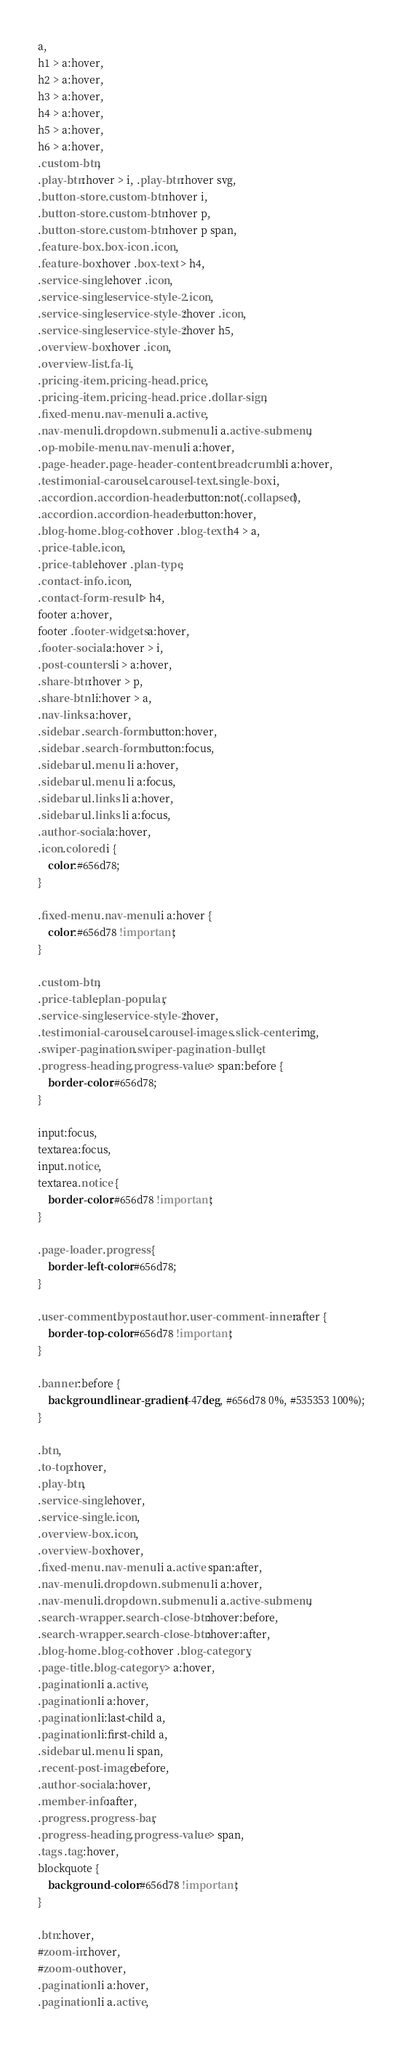Convert code to text. <code><loc_0><loc_0><loc_500><loc_500><_CSS_>a,
h1 > a:hover, 
h2 > a:hover, 
h3 > a:hover, 
h4 > a:hover, 
h5 > a:hover, 
h6 > a:hover,
.custom-btn,
.play-btn:hover > i, .play-btn:hover svg,
.button-store .custom-btn:hover i,
.button-store .custom-btn:hover p,
.button-store .custom-btn:hover p span,
.feature-box .box-icon .icon,
.feature-box:hover .box-text > h4,
.service-single:hover .icon,
.service-single.service-style-2 .icon,
.service-single.service-style-2:hover .icon,
.service-single.service-style-2:hover h5,
.overview-box:hover .icon,
.overview-list .fa-li,
.pricing-item .pricing-head .price,
.pricing-item .pricing-head .price .dollar-sign,
.fixed-menu .nav-menu li a.active,
.nav-menu li.dropdown .submenu li a.active-submenu,
.op-mobile-menu .nav-menu li a:hover,
.page-header .page-header-content .breadcrumb li a:hover,
.testimonial-carousel .carousel-text .single-box i,
.accordion .accordion-header button:not(.collapsed),
.accordion .accordion-header button:hover,
.blog-home .blog-col:hover .blog-text h4 > a,
.price-table .icon,
.price-table:hover .plan-type,
.contact-info .icon,
.contact-form-result > h4,
footer a:hover,
footer .footer-widgets a:hover,
.footer-social a:hover > i,
.post-counters li > a:hover,
.share-btn:hover > p,
.share-btn li:hover > a,
.nav-links a:hover,
.sidebar .search-form button:hover,
.sidebar .search-form button:focus,
.sidebar ul.menu li a:hover, 
.sidebar ul.menu li a:focus,
.sidebar ul.links li a:hover, 
.sidebar ul.links li a:focus,
.author-social a:hover,
.icon.colored i {
	color:#656d78;
}

.fixed-menu .nav-menu li a:hover {
	color:#656d78 !important;
}

.custom-btn,
.price-table.plan-popular,
.service-single.service-style-2:hover,
.testimonial-carousel .carousel-images .slick-center img,
.swiper-pagination .swiper-pagination-bullet,
.progress-heading .progress-value > span:before {
	border-color:#656d78;
}

input:focus, 
textarea:focus,
input.notice, 
textarea.notice {
	border-color:#656d78 !important;
}

.page-loader .progress {
	border-left-color:#656d78;
}

.user-comment.bypostauthor .user-comment-inner:after {
	border-top-color:#656d78 !important;
}

.banner:before {
	background:linear-gradient(-47deg, #656d78 0%, #535353 100%);
}

.btn,
.to-top:hover,
.play-btn,
.service-single:hover,
.service-single .icon,
.overview-box .icon,
.overview-box:hover,
.fixed-menu .nav-menu li a.active span:after,
.nav-menu li.dropdown .submenu li a:hover,
.nav-menu li.dropdown .submenu li a.active-submenu,
.search-wrapper .search-close-btn:hover:before,
.search-wrapper .search-close-btn:hover:after,
.blog-home .blog-col:hover .blog-category,
.page-title .blog-category > a:hover,
.pagination li a.active, 
.pagination li a:hover,
.pagination li:last-child a,
.pagination li:first-child a,
.sidebar ul.menu li span,
.recent-post-image:before,
.author-social a:hover,
.member-info:after,
.progress .progress-bar,
.progress-heading .progress-value > span,
.tags .tag:hover,
blockquote {
	background-color:#656d78 !important;
}

.btn:hover,
#zoom-in:hover, 
#zoom-out:hover,
.pagination li a:hover,	
.pagination li a.active, </code> 